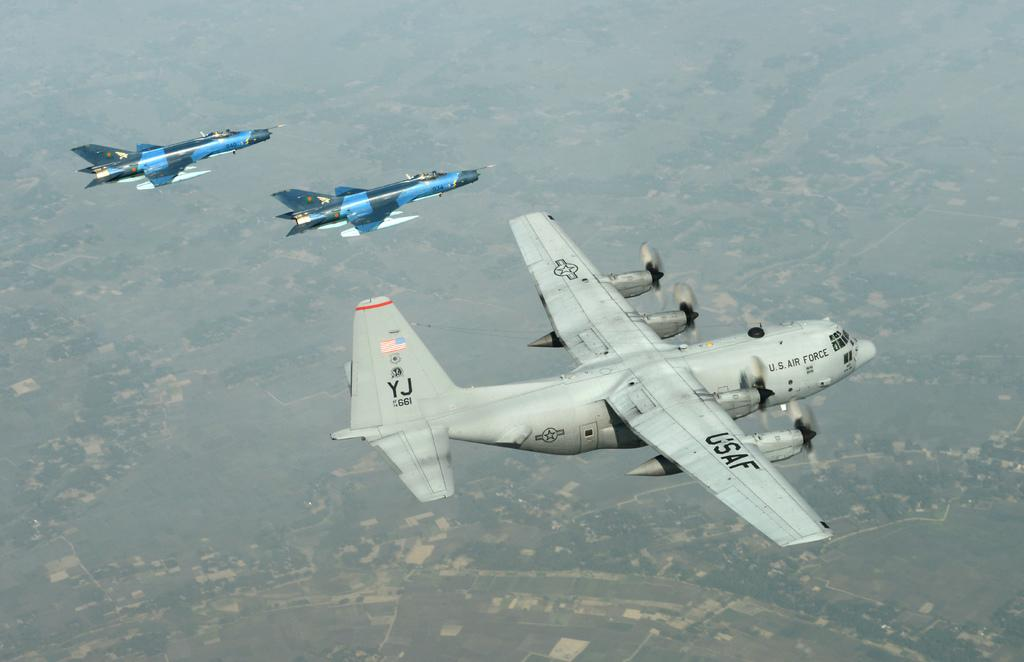<image>
Give a short and clear explanation of the subsequent image. A large usaf Plane flying with a smaller jet by its side. 